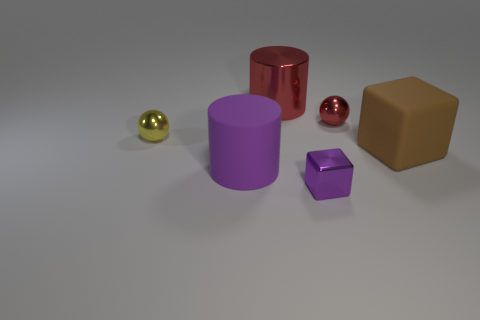Is the number of tiny yellow spheres that are in front of the large brown rubber cube greater than the number of big brown rubber things to the left of the yellow sphere?
Your answer should be compact. No. There is a small purple shiny object; does it have the same shape as the small object that is on the right side of the small purple metallic object?
Give a very brief answer. No. What number of other objects are there of the same shape as the large red shiny thing?
Ensure brevity in your answer.  1. What color is the tiny metal object that is both behind the tiny block and to the left of the red metal sphere?
Offer a very short reply. Yellow. What color is the big block?
Provide a succinct answer. Brown. Are the large red cylinder and the small ball that is on the right side of the yellow object made of the same material?
Your answer should be very brief. Yes. There is a purple thing that is made of the same material as the red cylinder; what shape is it?
Your answer should be very brief. Cube. There is a rubber cube that is the same size as the purple matte thing; what color is it?
Your response must be concise. Brown. Do the red shiny thing that is right of the metal cube and the large purple matte cylinder have the same size?
Keep it short and to the point. No. Is the large block the same color as the metallic cube?
Provide a short and direct response. No. 